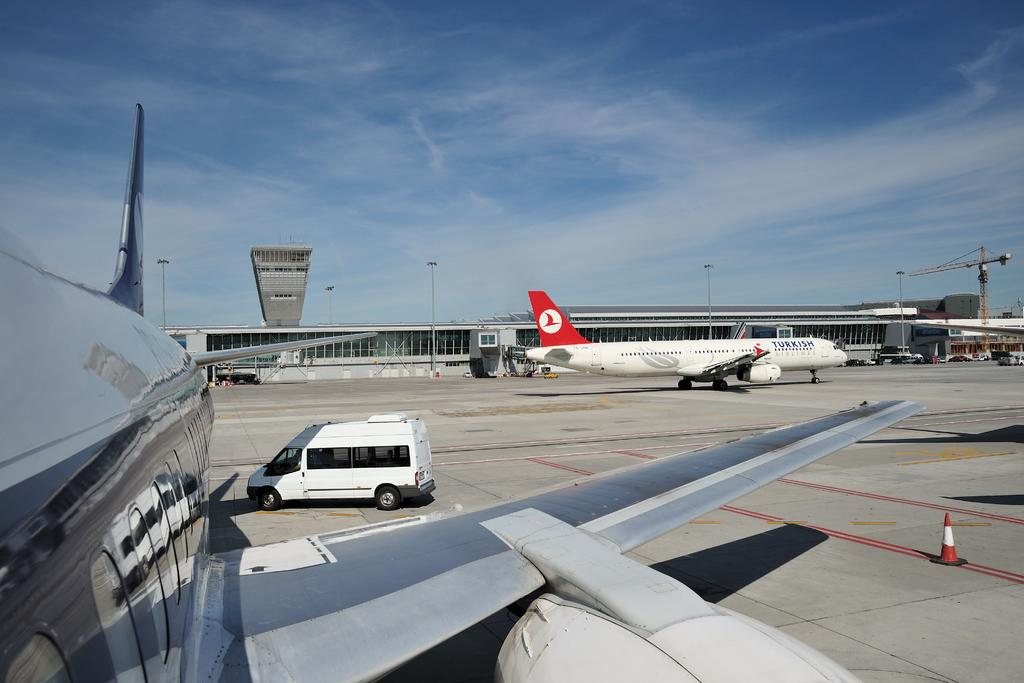What types of vehicles can be seen on the road in the image? There are vehicles on the road in the image. What other unusual objects are present on the road in the image? There are airplanes on the road in the image. What structures can be seen in the image? There are buildings visible in the image. What type of lighting is present in the image? Pole lights are present in the image. What else can be seen on the ground in the image? Other objects are visible on the ground in the image. What is visible in the background of the image? The sky is visible in the background of the image. Where is the table located in the image? There is no table present in the image. What type of crow can be seen interacting with the airplanes on the road in the image? There are no crows or chickens present in the image; it features vehicles, airplanes, and other objects on the road. 